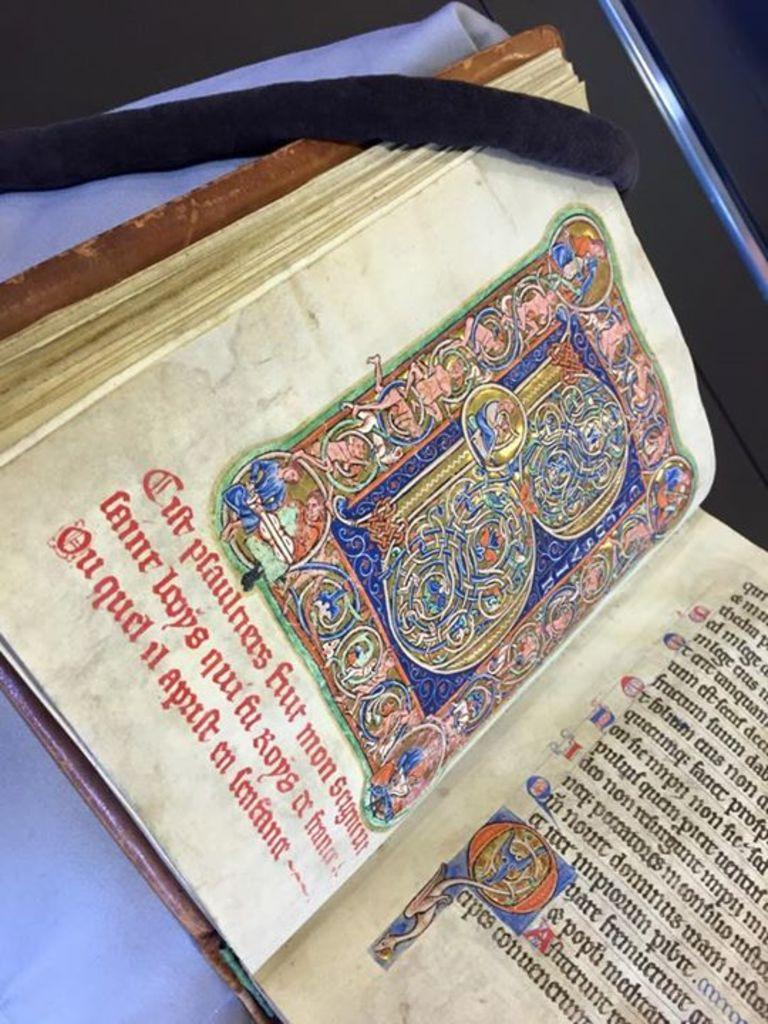<image>
Provide a brief description of the given image. A book in a foreign language where a line reads ou quel il apaft en femfana. 